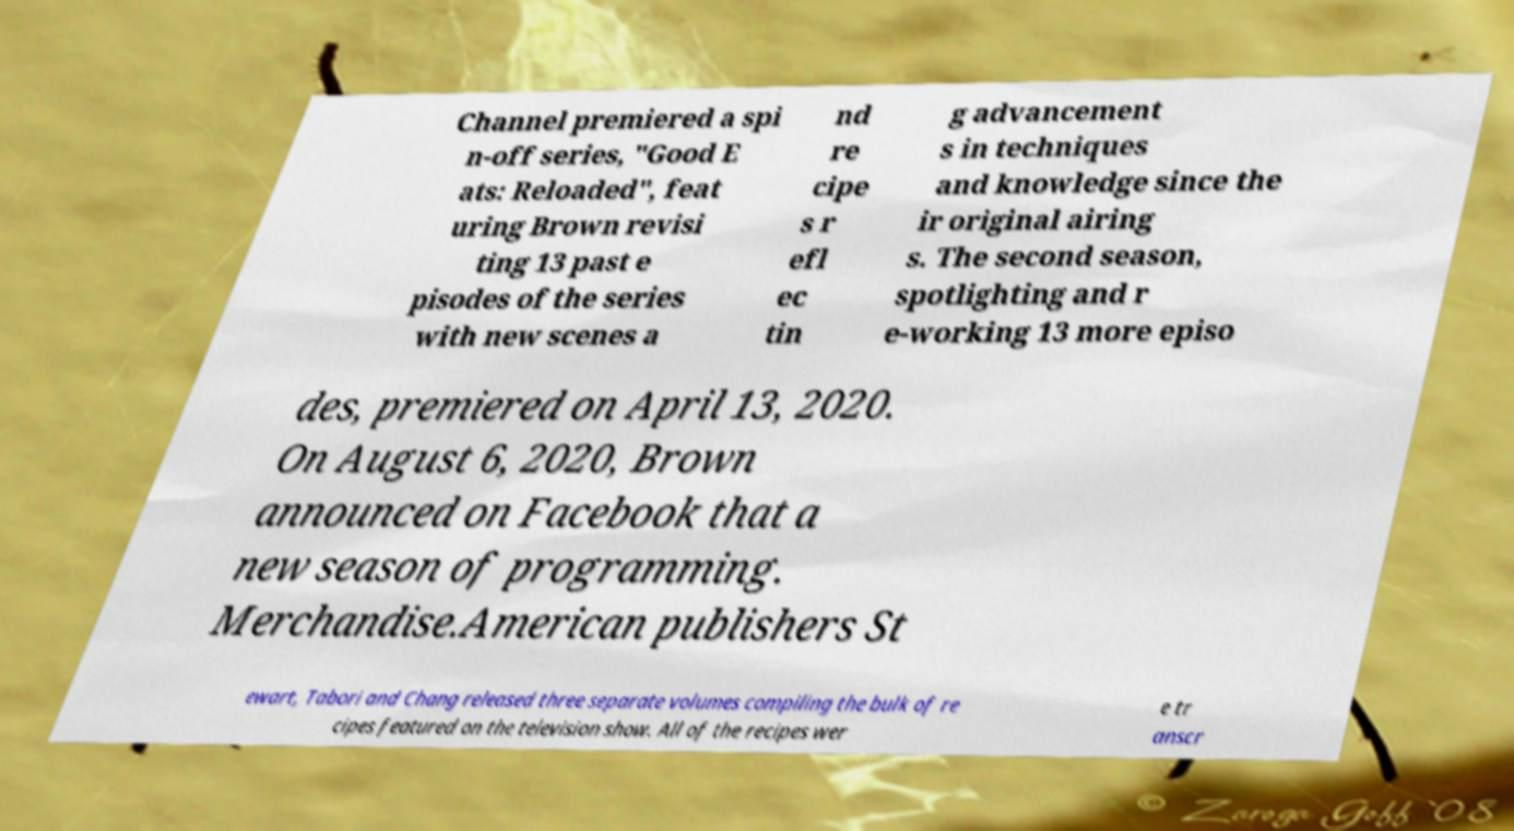There's text embedded in this image that I need extracted. Can you transcribe it verbatim? Channel premiered a spi n-off series, "Good E ats: Reloaded", feat uring Brown revisi ting 13 past e pisodes of the series with new scenes a nd re cipe s r efl ec tin g advancement s in techniques and knowledge since the ir original airing s. The second season, spotlighting and r e-working 13 more episo des, premiered on April 13, 2020. On August 6, 2020, Brown announced on Facebook that a new season of programming. Merchandise.American publishers St ewart, Tabori and Chang released three separate volumes compiling the bulk of re cipes featured on the television show. All of the recipes wer e tr anscr 